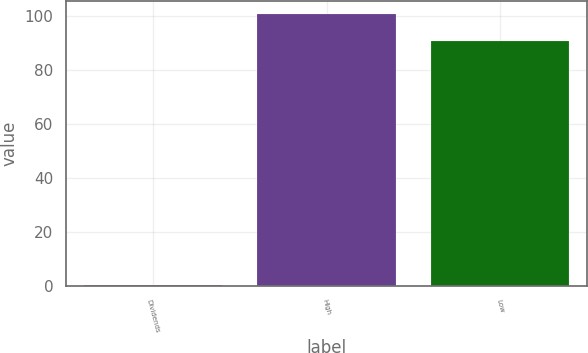Convert chart. <chart><loc_0><loc_0><loc_500><loc_500><bar_chart><fcel>Dividends<fcel>High<fcel>Low<nl><fcel>0.38<fcel>100.57<fcel>90.66<nl></chart> 